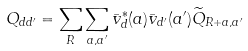<formula> <loc_0><loc_0><loc_500><loc_500>Q _ { d d ^ { \prime } } = \sum _ { R } \sum _ { { a } , { a ^ { \prime } } } { \bar { v } } _ { d } ^ { * } ( { a } ) { \bar { v } } _ { d ^ { \prime } } ( { a ^ { \prime } } ) \widetilde { Q } _ { { R } + { a } , { a ^ { \prime } } }</formula> 